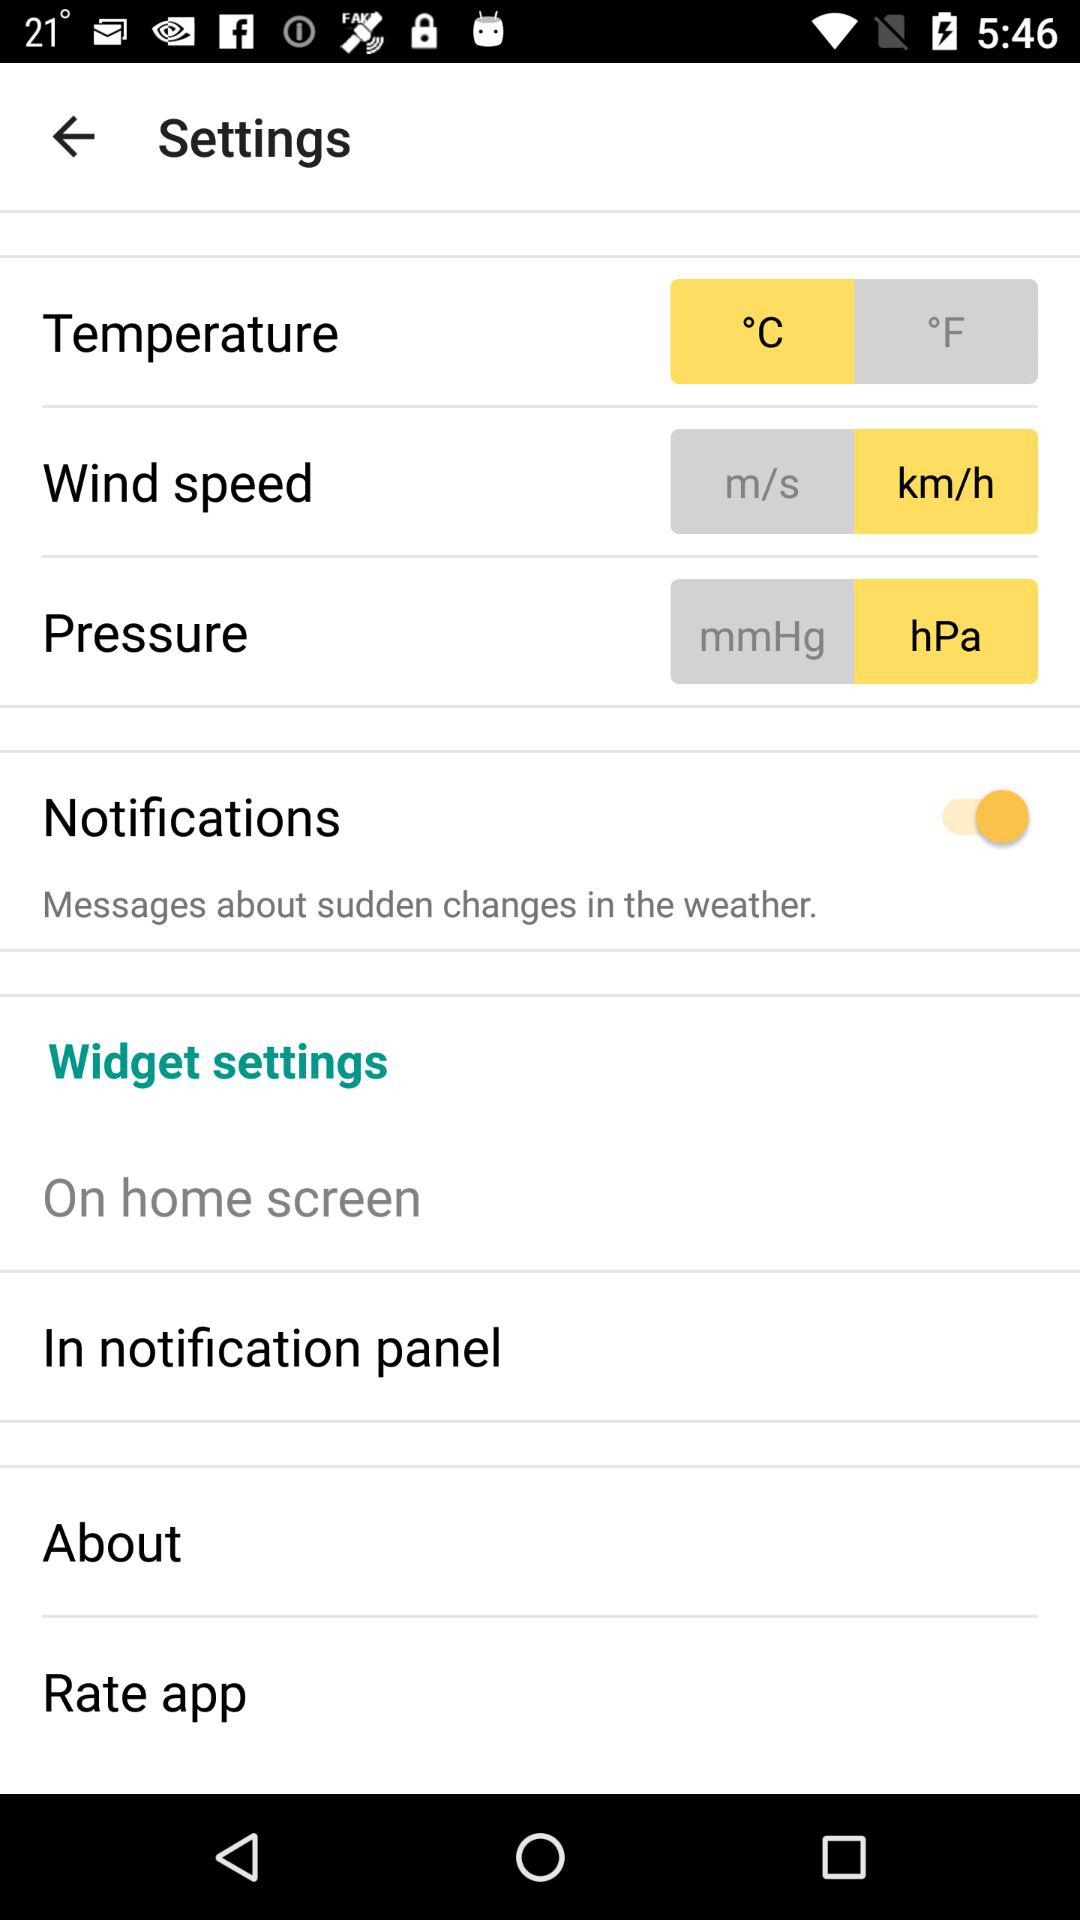How many units are available for wind speed?
Answer the question using a single word or phrase. 2 